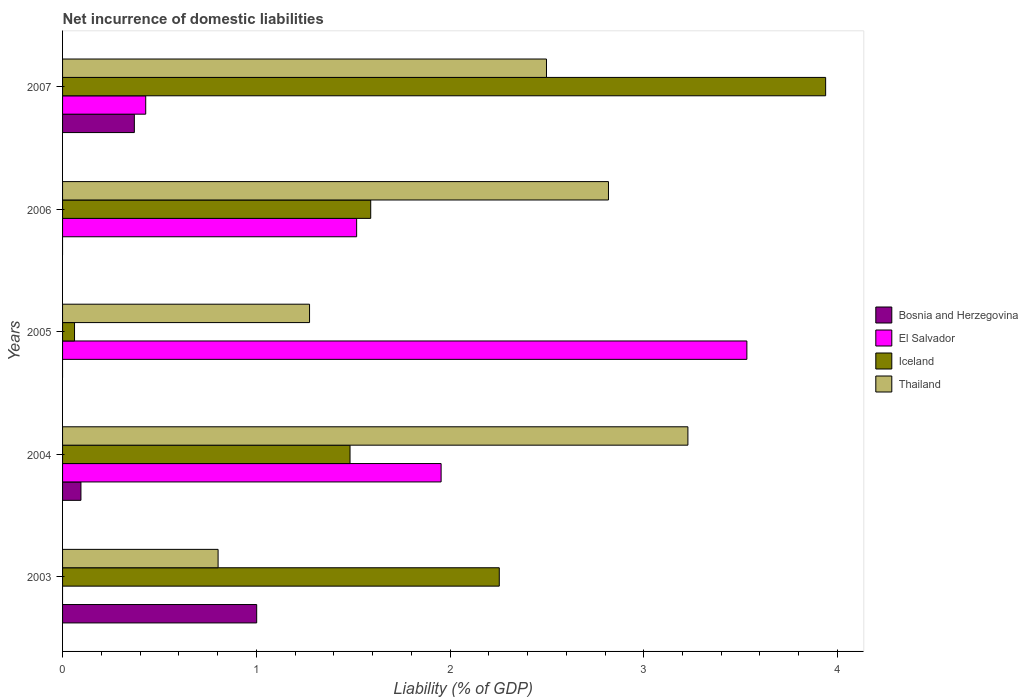How many groups of bars are there?
Provide a short and direct response. 5. In how many cases, is the number of bars for a given year not equal to the number of legend labels?
Provide a short and direct response. 3. What is the net incurrence of domestic liabilities in Iceland in 2007?
Keep it short and to the point. 3.94. Across all years, what is the maximum net incurrence of domestic liabilities in Bosnia and Herzegovina?
Make the answer very short. 1. In which year was the net incurrence of domestic liabilities in Iceland maximum?
Give a very brief answer. 2007. What is the total net incurrence of domestic liabilities in Iceland in the graph?
Your response must be concise. 9.33. What is the difference between the net incurrence of domestic liabilities in El Salvador in 2004 and that in 2007?
Make the answer very short. 1.52. What is the difference between the net incurrence of domestic liabilities in El Salvador in 2006 and the net incurrence of domestic liabilities in Bosnia and Herzegovina in 2003?
Ensure brevity in your answer.  0.52. What is the average net incurrence of domestic liabilities in Iceland per year?
Offer a very short reply. 1.87. In the year 2006, what is the difference between the net incurrence of domestic liabilities in Thailand and net incurrence of domestic liabilities in El Salvador?
Keep it short and to the point. 1.3. What is the ratio of the net incurrence of domestic liabilities in Thailand in 2005 to that in 2007?
Give a very brief answer. 0.51. Is the difference between the net incurrence of domestic liabilities in Thailand in 2004 and 2006 greater than the difference between the net incurrence of domestic liabilities in El Salvador in 2004 and 2006?
Provide a short and direct response. No. What is the difference between the highest and the second highest net incurrence of domestic liabilities in Thailand?
Your response must be concise. 0.41. What is the difference between the highest and the lowest net incurrence of domestic liabilities in El Salvador?
Your answer should be compact. 3.53. In how many years, is the net incurrence of domestic liabilities in Thailand greater than the average net incurrence of domestic liabilities in Thailand taken over all years?
Make the answer very short. 3. Is it the case that in every year, the sum of the net incurrence of domestic liabilities in Bosnia and Herzegovina and net incurrence of domestic liabilities in Iceland is greater than the net incurrence of domestic liabilities in Thailand?
Ensure brevity in your answer.  No. How many years are there in the graph?
Give a very brief answer. 5. What is the difference between two consecutive major ticks on the X-axis?
Your answer should be very brief. 1. Where does the legend appear in the graph?
Your answer should be compact. Center right. What is the title of the graph?
Ensure brevity in your answer.  Net incurrence of domestic liabilities. Does "Belgium" appear as one of the legend labels in the graph?
Your answer should be very brief. No. What is the label or title of the X-axis?
Your answer should be compact. Liability (% of GDP). What is the label or title of the Y-axis?
Give a very brief answer. Years. What is the Liability (% of GDP) of Bosnia and Herzegovina in 2003?
Your response must be concise. 1. What is the Liability (% of GDP) of Iceland in 2003?
Your response must be concise. 2.25. What is the Liability (% of GDP) in Thailand in 2003?
Ensure brevity in your answer.  0.8. What is the Liability (% of GDP) in Bosnia and Herzegovina in 2004?
Ensure brevity in your answer.  0.09. What is the Liability (% of GDP) in El Salvador in 2004?
Your answer should be compact. 1.95. What is the Liability (% of GDP) in Iceland in 2004?
Keep it short and to the point. 1.48. What is the Liability (% of GDP) of Thailand in 2004?
Your response must be concise. 3.23. What is the Liability (% of GDP) in Bosnia and Herzegovina in 2005?
Offer a very short reply. 0. What is the Liability (% of GDP) of El Salvador in 2005?
Offer a terse response. 3.53. What is the Liability (% of GDP) of Iceland in 2005?
Keep it short and to the point. 0.06. What is the Liability (% of GDP) of Thailand in 2005?
Give a very brief answer. 1.27. What is the Liability (% of GDP) in Bosnia and Herzegovina in 2006?
Make the answer very short. 0. What is the Liability (% of GDP) in El Salvador in 2006?
Your response must be concise. 1.52. What is the Liability (% of GDP) in Iceland in 2006?
Your answer should be very brief. 1.59. What is the Liability (% of GDP) in Thailand in 2006?
Your answer should be compact. 2.82. What is the Liability (% of GDP) in Bosnia and Herzegovina in 2007?
Offer a terse response. 0.37. What is the Liability (% of GDP) in El Salvador in 2007?
Keep it short and to the point. 0.43. What is the Liability (% of GDP) of Iceland in 2007?
Offer a very short reply. 3.94. What is the Liability (% of GDP) of Thailand in 2007?
Make the answer very short. 2.5. Across all years, what is the maximum Liability (% of GDP) in Bosnia and Herzegovina?
Your response must be concise. 1. Across all years, what is the maximum Liability (% of GDP) of El Salvador?
Offer a very short reply. 3.53. Across all years, what is the maximum Liability (% of GDP) in Iceland?
Your response must be concise. 3.94. Across all years, what is the maximum Liability (% of GDP) of Thailand?
Keep it short and to the point. 3.23. Across all years, what is the minimum Liability (% of GDP) of El Salvador?
Provide a succinct answer. 0. Across all years, what is the minimum Liability (% of GDP) of Iceland?
Offer a very short reply. 0.06. Across all years, what is the minimum Liability (% of GDP) in Thailand?
Provide a succinct answer. 0.8. What is the total Liability (% of GDP) of Bosnia and Herzegovina in the graph?
Keep it short and to the point. 1.47. What is the total Liability (% of GDP) in El Salvador in the graph?
Ensure brevity in your answer.  7.43. What is the total Liability (% of GDP) of Iceland in the graph?
Provide a short and direct response. 9.33. What is the total Liability (% of GDP) of Thailand in the graph?
Your response must be concise. 10.62. What is the difference between the Liability (% of GDP) of Bosnia and Herzegovina in 2003 and that in 2004?
Your response must be concise. 0.91. What is the difference between the Liability (% of GDP) of Iceland in 2003 and that in 2004?
Offer a terse response. 0.77. What is the difference between the Liability (% of GDP) in Thailand in 2003 and that in 2004?
Provide a short and direct response. -2.43. What is the difference between the Liability (% of GDP) of Iceland in 2003 and that in 2005?
Offer a very short reply. 2.19. What is the difference between the Liability (% of GDP) of Thailand in 2003 and that in 2005?
Your response must be concise. -0.47. What is the difference between the Liability (% of GDP) of Iceland in 2003 and that in 2006?
Offer a very short reply. 0.66. What is the difference between the Liability (% of GDP) of Thailand in 2003 and that in 2006?
Provide a succinct answer. -2.02. What is the difference between the Liability (% of GDP) of Bosnia and Herzegovina in 2003 and that in 2007?
Your response must be concise. 0.63. What is the difference between the Liability (% of GDP) of Iceland in 2003 and that in 2007?
Give a very brief answer. -1.68. What is the difference between the Liability (% of GDP) in Thailand in 2003 and that in 2007?
Provide a short and direct response. -1.7. What is the difference between the Liability (% of GDP) of El Salvador in 2004 and that in 2005?
Provide a succinct answer. -1.58. What is the difference between the Liability (% of GDP) in Iceland in 2004 and that in 2005?
Your answer should be compact. 1.42. What is the difference between the Liability (% of GDP) in Thailand in 2004 and that in 2005?
Give a very brief answer. 1.95. What is the difference between the Liability (% of GDP) in El Salvador in 2004 and that in 2006?
Provide a succinct answer. 0.44. What is the difference between the Liability (% of GDP) in Iceland in 2004 and that in 2006?
Make the answer very short. -0.11. What is the difference between the Liability (% of GDP) in Thailand in 2004 and that in 2006?
Your answer should be compact. 0.41. What is the difference between the Liability (% of GDP) of Bosnia and Herzegovina in 2004 and that in 2007?
Make the answer very short. -0.28. What is the difference between the Liability (% of GDP) of El Salvador in 2004 and that in 2007?
Your answer should be very brief. 1.52. What is the difference between the Liability (% of GDP) in Iceland in 2004 and that in 2007?
Offer a very short reply. -2.46. What is the difference between the Liability (% of GDP) in Thailand in 2004 and that in 2007?
Make the answer very short. 0.73. What is the difference between the Liability (% of GDP) of El Salvador in 2005 and that in 2006?
Ensure brevity in your answer.  2.01. What is the difference between the Liability (% of GDP) of Iceland in 2005 and that in 2006?
Provide a short and direct response. -1.53. What is the difference between the Liability (% of GDP) in Thailand in 2005 and that in 2006?
Your answer should be compact. -1.54. What is the difference between the Liability (% of GDP) in El Salvador in 2005 and that in 2007?
Your answer should be very brief. 3.1. What is the difference between the Liability (% of GDP) in Iceland in 2005 and that in 2007?
Ensure brevity in your answer.  -3.88. What is the difference between the Liability (% of GDP) in Thailand in 2005 and that in 2007?
Keep it short and to the point. -1.22. What is the difference between the Liability (% of GDP) of El Salvador in 2006 and that in 2007?
Make the answer very short. 1.09. What is the difference between the Liability (% of GDP) of Iceland in 2006 and that in 2007?
Ensure brevity in your answer.  -2.35. What is the difference between the Liability (% of GDP) of Thailand in 2006 and that in 2007?
Make the answer very short. 0.32. What is the difference between the Liability (% of GDP) in Bosnia and Herzegovina in 2003 and the Liability (% of GDP) in El Salvador in 2004?
Offer a very short reply. -0.95. What is the difference between the Liability (% of GDP) in Bosnia and Herzegovina in 2003 and the Liability (% of GDP) in Iceland in 2004?
Offer a very short reply. -0.48. What is the difference between the Liability (% of GDP) of Bosnia and Herzegovina in 2003 and the Liability (% of GDP) of Thailand in 2004?
Keep it short and to the point. -2.23. What is the difference between the Liability (% of GDP) in Iceland in 2003 and the Liability (% of GDP) in Thailand in 2004?
Your answer should be very brief. -0.97. What is the difference between the Liability (% of GDP) in Bosnia and Herzegovina in 2003 and the Liability (% of GDP) in El Salvador in 2005?
Offer a terse response. -2.53. What is the difference between the Liability (% of GDP) in Bosnia and Herzegovina in 2003 and the Liability (% of GDP) in Iceland in 2005?
Offer a very short reply. 0.94. What is the difference between the Liability (% of GDP) of Bosnia and Herzegovina in 2003 and the Liability (% of GDP) of Thailand in 2005?
Offer a terse response. -0.27. What is the difference between the Liability (% of GDP) of Iceland in 2003 and the Liability (% of GDP) of Thailand in 2005?
Give a very brief answer. 0.98. What is the difference between the Liability (% of GDP) of Bosnia and Herzegovina in 2003 and the Liability (% of GDP) of El Salvador in 2006?
Your response must be concise. -0.52. What is the difference between the Liability (% of GDP) of Bosnia and Herzegovina in 2003 and the Liability (% of GDP) of Iceland in 2006?
Offer a terse response. -0.59. What is the difference between the Liability (% of GDP) of Bosnia and Herzegovina in 2003 and the Liability (% of GDP) of Thailand in 2006?
Your answer should be compact. -1.82. What is the difference between the Liability (% of GDP) in Iceland in 2003 and the Liability (% of GDP) in Thailand in 2006?
Your answer should be compact. -0.56. What is the difference between the Liability (% of GDP) of Bosnia and Herzegovina in 2003 and the Liability (% of GDP) of El Salvador in 2007?
Your response must be concise. 0.57. What is the difference between the Liability (% of GDP) in Bosnia and Herzegovina in 2003 and the Liability (% of GDP) in Iceland in 2007?
Provide a short and direct response. -2.94. What is the difference between the Liability (% of GDP) of Bosnia and Herzegovina in 2003 and the Liability (% of GDP) of Thailand in 2007?
Make the answer very short. -1.5. What is the difference between the Liability (% of GDP) of Iceland in 2003 and the Liability (% of GDP) of Thailand in 2007?
Offer a very short reply. -0.24. What is the difference between the Liability (% of GDP) in Bosnia and Herzegovina in 2004 and the Liability (% of GDP) in El Salvador in 2005?
Your answer should be compact. -3.44. What is the difference between the Liability (% of GDP) in Bosnia and Herzegovina in 2004 and the Liability (% of GDP) in Iceland in 2005?
Provide a short and direct response. 0.03. What is the difference between the Liability (% of GDP) of Bosnia and Herzegovina in 2004 and the Liability (% of GDP) of Thailand in 2005?
Offer a very short reply. -1.18. What is the difference between the Liability (% of GDP) in El Salvador in 2004 and the Liability (% of GDP) in Iceland in 2005?
Provide a succinct answer. 1.89. What is the difference between the Liability (% of GDP) in El Salvador in 2004 and the Liability (% of GDP) in Thailand in 2005?
Make the answer very short. 0.68. What is the difference between the Liability (% of GDP) of Iceland in 2004 and the Liability (% of GDP) of Thailand in 2005?
Ensure brevity in your answer.  0.21. What is the difference between the Liability (% of GDP) of Bosnia and Herzegovina in 2004 and the Liability (% of GDP) of El Salvador in 2006?
Provide a short and direct response. -1.42. What is the difference between the Liability (% of GDP) in Bosnia and Herzegovina in 2004 and the Liability (% of GDP) in Iceland in 2006?
Give a very brief answer. -1.5. What is the difference between the Liability (% of GDP) of Bosnia and Herzegovina in 2004 and the Liability (% of GDP) of Thailand in 2006?
Provide a short and direct response. -2.72. What is the difference between the Liability (% of GDP) in El Salvador in 2004 and the Liability (% of GDP) in Iceland in 2006?
Your response must be concise. 0.36. What is the difference between the Liability (% of GDP) of El Salvador in 2004 and the Liability (% of GDP) of Thailand in 2006?
Make the answer very short. -0.86. What is the difference between the Liability (% of GDP) of Iceland in 2004 and the Liability (% of GDP) of Thailand in 2006?
Your response must be concise. -1.33. What is the difference between the Liability (% of GDP) of Bosnia and Herzegovina in 2004 and the Liability (% of GDP) of El Salvador in 2007?
Give a very brief answer. -0.33. What is the difference between the Liability (% of GDP) in Bosnia and Herzegovina in 2004 and the Liability (% of GDP) in Iceland in 2007?
Ensure brevity in your answer.  -3.84. What is the difference between the Liability (% of GDP) of Bosnia and Herzegovina in 2004 and the Liability (% of GDP) of Thailand in 2007?
Provide a succinct answer. -2.4. What is the difference between the Liability (% of GDP) in El Salvador in 2004 and the Liability (% of GDP) in Iceland in 2007?
Provide a succinct answer. -1.98. What is the difference between the Liability (% of GDP) of El Salvador in 2004 and the Liability (% of GDP) of Thailand in 2007?
Offer a terse response. -0.54. What is the difference between the Liability (% of GDP) in Iceland in 2004 and the Liability (% of GDP) in Thailand in 2007?
Give a very brief answer. -1.01. What is the difference between the Liability (% of GDP) of El Salvador in 2005 and the Liability (% of GDP) of Iceland in 2006?
Your response must be concise. 1.94. What is the difference between the Liability (% of GDP) of El Salvador in 2005 and the Liability (% of GDP) of Thailand in 2006?
Your response must be concise. 0.71. What is the difference between the Liability (% of GDP) of Iceland in 2005 and the Liability (% of GDP) of Thailand in 2006?
Offer a very short reply. -2.76. What is the difference between the Liability (% of GDP) of El Salvador in 2005 and the Liability (% of GDP) of Iceland in 2007?
Offer a terse response. -0.41. What is the difference between the Liability (% of GDP) in El Salvador in 2005 and the Liability (% of GDP) in Thailand in 2007?
Provide a short and direct response. 1.03. What is the difference between the Liability (% of GDP) in Iceland in 2005 and the Liability (% of GDP) in Thailand in 2007?
Your response must be concise. -2.44. What is the difference between the Liability (% of GDP) of El Salvador in 2006 and the Liability (% of GDP) of Iceland in 2007?
Give a very brief answer. -2.42. What is the difference between the Liability (% of GDP) of El Salvador in 2006 and the Liability (% of GDP) of Thailand in 2007?
Give a very brief answer. -0.98. What is the difference between the Liability (% of GDP) in Iceland in 2006 and the Liability (% of GDP) in Thailand in 2007?
Offer a terse response. -0.91. What is the average Liability (% of GDP) in Bosnia and Herzegovina per year?
Offer a very short reply. 0.29. What is the average Liability (% of GDP) in El Salvador per year?
Offer a very short reply. 1.49. What is the average Liability (% of GDP) of Iceland per year?
Give a very brief answer. 1.87. What is the average Liability (% of GDP) in Thailand per year?
Make the answer very short. 2.12. In the year 2003, what is the difference between the Liability (% of GDP) of Bosnia and Herzegovina and Liability (% of GDP) of Iceland?
Your response must be concise. -1.25. In the year 2003, what is the difference between the Liability (% of GDP) in Bosnia and Herzegovina and Liability (% of GDP) in Thailand?
Your answer should be very brief. 0.2. In the year 2003, what is the difference between the Liability (% of GDP) of Iceland and Liability (% of GDP) of Thailand?
Your answer should be very brief. 1.45. In the year 2004, what is the difference between the Liability (% of GDP) in Bosnia and Herzegovina and Liability (% of GDP) in El Salvador?
Offer a terse response. -1.86. In the year 2004, what is the difference between the Liability (% of GDP) in Bosnia and Herzegovina and Liability (% of GDP) in Iceland?
Offer a very short reply. -1.39. In the year 2004, what is the difference between the Liability (% of GDP) of Bosnia and Herzegovina and Liability (% of GDP) of Thailand?
Your answer should be compact. -3.13. In the year 2004, what is the difference between the Liability (% of GDP) of El Salvador and Liability (% of GDP) of Iceland?
Your answer should be compact. 0.47. In the year 2004, what is the difference between the Liability (% of GDP) in El Salvador and Liability (% of GDP) in Thailand?
Offer a very short reply. -1.27. In the year 2004, what is the difference between the Liability (% of GDP) of Iceland and Liability (% of GDP) of Thailand?
Your answer should be compact. -1.74. In the year 2005, what is the difference between the Liability (% of GDP) of El Salvador and Liability (% of GDP) of Iceland?
Make the answer very short. 3.47. In the year 2005, what is the difference between the Liability (% of GDP) in El Salvador and Liability (% of GDP) in Thailand?
Provide a succinct answer. 2.26. In the year 2005, what is the difference between the Liability (% of GDP) of Iceland and Liability (% of GDP) of Thailand?
Provide a short and direct response. -1.21. In the year 2006, what is the difference between the Liability (% of GDP) of El Salvador and Liability (% of GDP) of Iceland?
Your answer should be very brief. -0.07. In the year 2006, what is the difference between the Liability (% of GDP) in El Salvador and Liability (% of GDP) in Thailand?
Your answer should be very brief. -1.3. In the year 2006, what is the difference between the Liability (% of GDP) of Iceland and Liability (% of GDP) of Thailand?
Your answer should be compact. -1.23. In the year 2007, what is the difference between the Liability (% of GDP) of Bosnia and Herzegovina and Liability (% of GDP) of El Salvador?
Make the answer very short. -0.06. In the year 2007, what is the difference between the Liability (% of GDP) in Bosnia and Herzegovina and Liability (% of GDP) in Iceland?
Ensure brevity in your answer.  -3.57. In the year 2007, what is the difference between the Liability (% of GDP) of Bosnia and Herzegovina and Liability (% of GDP) of Thailand?
Offer a very short reply. -2.13. In the year 2007, what is the difference between the Liability (% of GDP) of El Salvador and Liability (% of GDP) of Iceland?
Offer a very short reply. -3.51. In the year 2007, what is the difference between the Liability (% of GDP) in El Salvador and Liability (% of GDP) in Thailand?
Your answer should be compact. -2.07. In the year 2007, what is the difference between the Liability (% of GDP) in Iceland and Liability (% of GDP) in Thailand?
Give a very brief answer. 1.44. What is the ratio of the Liability (% of GDP) of Bosnia and Herzegovina in 2003 to that in 2004?
Your answer should be compact. 10.57. What is the ratio of the Liability (% of GDP) in Iceland in 2003 to that in 2004?
Provide a succinct answer. 1.52. What is the ratio of the Liability (% of GDP) of Thailand in 2003 to that in 2004?
Provide a succinct answer. 0.25. What is the ratio of the Liability (% of GDP) of Iceland in 2003 to that in 2005?
Offer a very short reply. 36.49. What is the ratio of the Liability (% of GDP) of Thailand in 2003 to that in 2005?
Provide a succinct answer. 0.63. What is the ratio of the Liability (% of GDP) in Iceland in 2003 to that in 2006?
Offer a terse response. 1.42. What is the ratio of the Liability (% of GDP) of Thailand in 2003 to that in 2006?
Ensure brevity in your answer.  0.28. What is the ratio of the Liability (% of GDP) of Bosnia and Herzegovina in 2003 to that in 2007?
Offer a very short reply. 2.7. What is the ratio of the Liability (% of GDP) of Iceland in 2003 to that in 2007?
Your response must be concise. 0.57. What is the ratio of the Liability (% of GDP) of Thailand in 2003 to that in 2007?
Provide a short and direct response. 0.32. What is the ratio of the Liability (% of GDP) in El Salvador in 2004 to that in 2005?
Keep it short and to the point. 0.55. What is the ratio of the Liability (% of GDP) of Iceland in 2004 to that in 2005?
Your response must be concise. 24.02. What is the ratio of the Liability (% of GDP) of Thailand in 2004 to that in 2005?
Make the answer very short. 2.53. What is the ratio of the Liability (% of GDP) of El Salvador in 2004 to that in 2006?
Keep it short and to the point. 1.29. What is the ratio of the Liability (% of GDP) in Iceland in 2004 to that in 2006?
Your answer should be very brief. 0.93. What is the ratio of the Liability (% of GDP) of Thailand in 2004 to that in 2006?
Provide a short and direct response. 1.15. What is the ratio of the Liability (% of GDP) in Bosnia and Herzegovina in 2004 to that in 2007?
Your answer should be very brief. 0.26. What is the ratio of the Liability (% of GDP) of El Salvador in 2004 to that in 2007?
Keep it short and to the point. 4.55. What is the ratio of the Liability (% of GDP) of Iceland in 2004 to that in 2007?
Offer a very short reply. 0.38. What is the ratio of the Liability (% of GDP) in Thailand in 2004 to that in 2007?
Provide a succinct answer. 1.29. What is the ratio of the Liability (% of GDP) in El Salvador in 2005 to that in 2006?
Your answer should be compact. 2.33. What is the ratio of the Liability (% of GDP) in Iceland in 2005 to that in 2006?
Give a very brief answer. 0.04. What is the ratio of the Liability (% of GDP) in Thailand in 2005 to that in 2006?
Your answer should be very brief. 0.45. What is the ratio of the Liability (% of GDP) in El Salvador in 2005 to that in 2007?
Offer a terse response. 8.23. What is the ratio of the Liability (% of GDP) in Iceland in 2005 to that in 2007?
Offer a terse response. 0.02. What is the ratio of the Liability (% of GDP) in Thailand in 2005 to that in 2007?
Make the answer very short. 0.51. What is the ratio of the Liability (% of GDP) in El Salvador in 2006 to that in 2007?
Provide a short and direct response. 3.54. What is the ratio of the Liability (% of GDP) of Iceland in 2006 to that in 2007?
Offer a terse response. 0.4. What is the ratio of the Liability (% of GDP) of Thailand in 2006 to that in 2007?
Ensure brevity in your answer.  1.13. What is the difference between the highest and the second highest Liability (% of GDP) of Bosnia and Herzegovina?
Give a very brief answer. 0.63. What is the difference between the highest and the second highest Liability (% of GDP) in El Salvador?
Make the answer very short. 1.58. What is the difference between the highest and the second highest Liability (% of GDP) in Iceland?
Your answer should be very brief. 1.68. What is the difference between the highest and the second highest Liability (% of GDP) in Thailand?
Make the answer very short. 0.41. What is the difference between the highest and the lowest Liability (% of GDP) in El Salvador?
Your response must be concise. 3.53. What is the difference between the highest and the lowest Liability (% of GDP) of Iceland?
Keep it short and to the point. 3.88. What is the difference between the highest and the lowest Liability (% of GDP) of Thailand?
Your response must be concise. 2.43. 